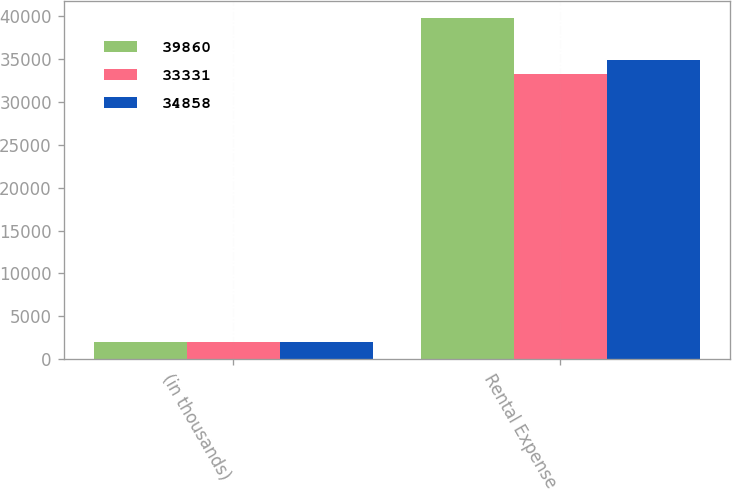Convert chart to OTSL. <chart><loc_0><loc_0><loc_500><loc_500><stacked_bar_chart><ecel><fcel>(in thousands)<fcel>Rental Expense<nl><fcel>39860<fcel>2008<fcel>39860<nl><fcel>33331<fcel>2007<fcel>33331<nl><fcel>34858<fcel>2006<fcel>34858<nl></chart> 